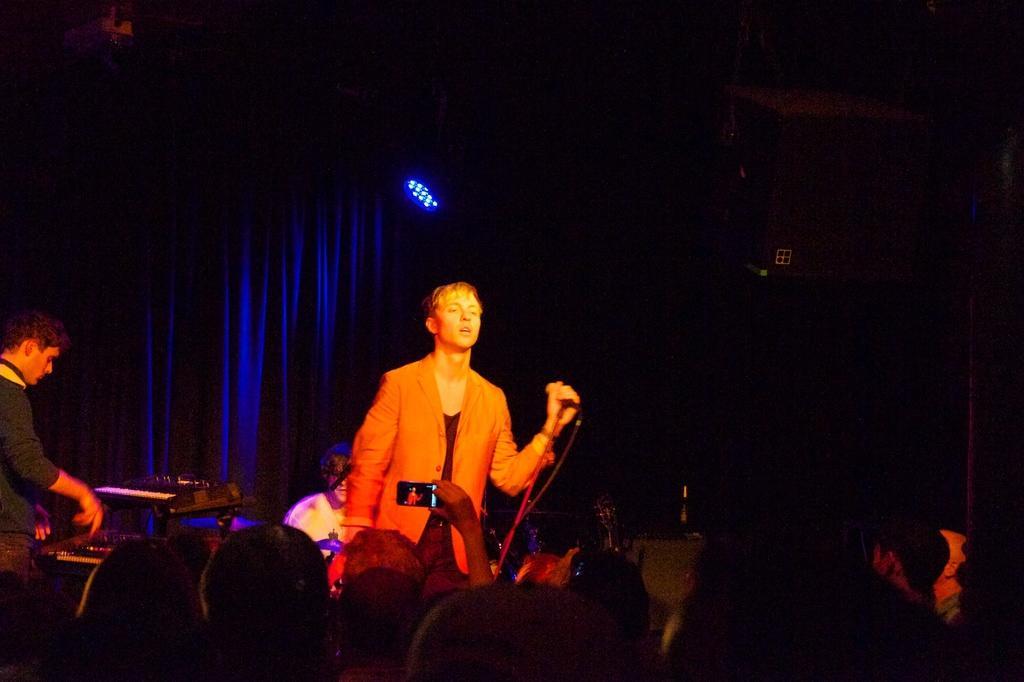Please provide a concise description of this image. There are two men standing. This man is holding a mike, which is attached to the mike stand. On the left side of the image, I can see another person playing piano. At the bottom of the image, I can see a group of people standing. I can see a person holding a mobile phone and clicking pictures. This looks like a cloth hanging. I think this is a show light. Here is a another person sitting. The background looks dark. 